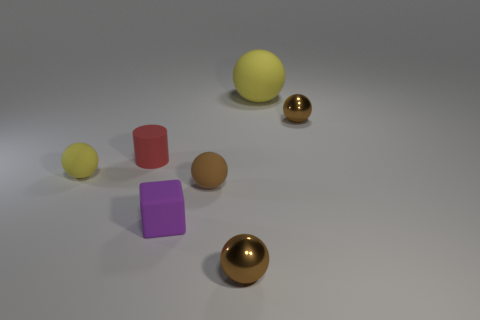How many brown balls must be subtracted to get 1 brown balls? 2 Subtract all small brown metal spheres. How many spheres are left? 3 Subtract 1 blocks. How many blocks are left? 0 Subtract all yellow balls. How many balls are left? 3 Add 1 small cylinders. How many objects exist? 8 Subtract all cylinders. How many objects are left? 6 Subtract all small brown balls. Subtract all large rubber objects. How many objects are left? 3 Add 6 yellow things. How many yellow things are left? 8 Add 7 brown metallic balls. How many brown metallic balls exist? 9 Subtract 1 purple cubes. How many objects are left? 6 